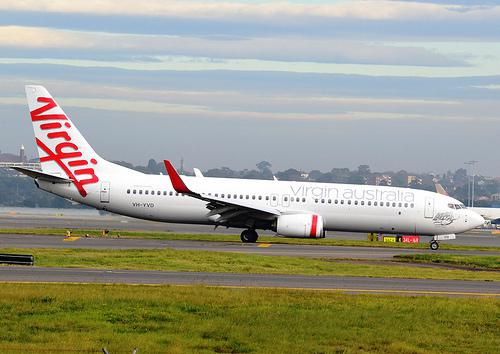Question: what is the airline company?
Choices:
A. Southwest.
B. United.
C. British airways.
D. Virgin.
Answer with the letter. Answer: D Question: what is this picture of?
Choices:
A. A house.
B. A rainbow.
C. A clown.
D. A plane.
Answer with the letter. Answer: D Question: where was this photo taken?
Choices:
A. Fair.
B. An airport.
C. Carnival.
D. Outside.
Answer with the letter. Answer: B 